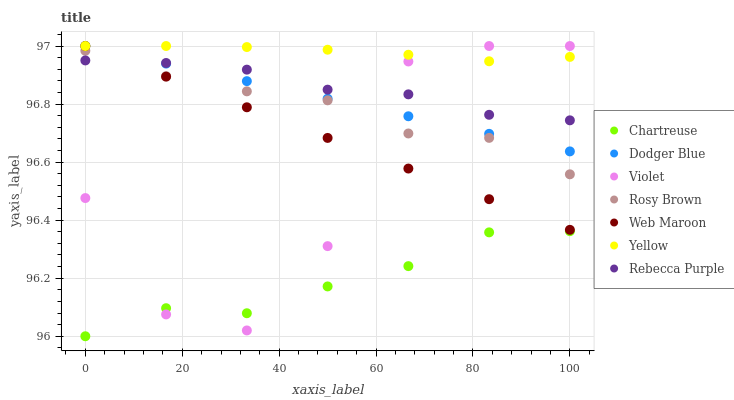Does Chartreuse have the minimum area under the curve?
Answer yes or no. Yes. Does Yellow have the maximum area under the curve?
Answer yes or no. Yes. Does Web Maroon have the minimum area under the curve?
Answer yes or no. No. Does Web Maroon have the maximum area under the curve?
Answer yes or no. No. Is Web Maroon the smoothest?
Answer yes or no. Yes. Is Violet the roughest?
Answer yes or no. Yes. Is Yellow the smoothest?
Answer yes or no. No. Is Yellow the roughest?
Answer yes or no. No. Does Chartreuse have the lowest value?
Answer yes or no. Yes. Does Web Maroon have the lowest value?
Answer yes or no. No. Does Violet have the highest value?
Answer yes or no. Yes. Does Chartreuse have the highest value?
Answer yes or no. No. Is Chartreuse less than Rebecca Purple?
Answer yes or no. Yes. Is Dodger Blue greater than Chartreuse?
Answer yes or no. Yes. Does Yellow intersect Dodger Blue?
Answer yes or no. Yes. Is Yellow less than Dodger Blue?
Answer yes or no. No. Is Yellow greater than Dodger Blue?
Answer yes or no. No. Does Chartreuse intersect Rebecca Purple?
Answer yes or no. No. 